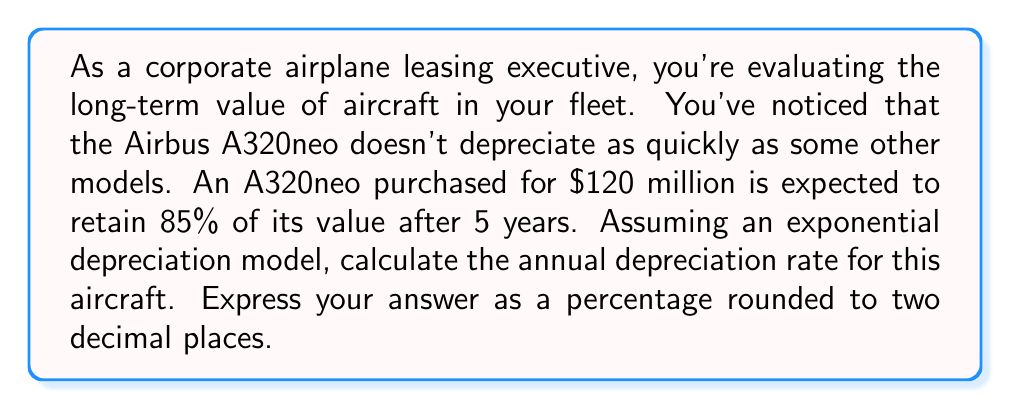Can you answer this question? To solve this problem, we'll use the exponential decay function:

$$ V(t) = V_0 \cdot (1-r)^t $$

Where:
$V(t)$ is the value after time $t$
$V_0$ is the initial value
$r$ is the annual depreciation rate
$t$ is the time in years

We know:
$V_0 = \$120$ million
$V(5) = 85\% \cdot \$120$ million $= \$102$ million
$t = 5$ years

Let's plug these values into the equation:

$$ 102 = 120 \cdot (1-r)^5 $$

Dividing both sides by 120:

$$ \frac{102}{120} = (1-r)^5 $$

$$ 0.85 = (1-r)^5 $$

Taking the fifth root of both sides:

$$ \sqrt[5]{0.85} = 1-r $$

$$ 0.9679 = 1-r $$

Solving for $r$:

$$ r = 1 - 0.9679 = 0.0321 $$

Converting to a percentage:

$$ r = 3.21\% $$
Answer: The annual depreciation rate for the Airbus A320neo is 3.21%. 